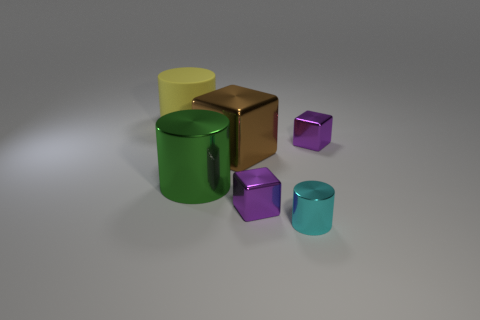Add 2 tiny green rubber cubes. How many objects exist? 8 Add 3 matte cylinders. How many matte cylinders exist? 4 Subtract 0 cyan spheres. How many objects are left? 6 Subtract all tiny blocks. Subtract all tiny purple metallic cubes. How many objects are left? 2 Add 3 shiny cubes. How many shiny cubes are left? 6 